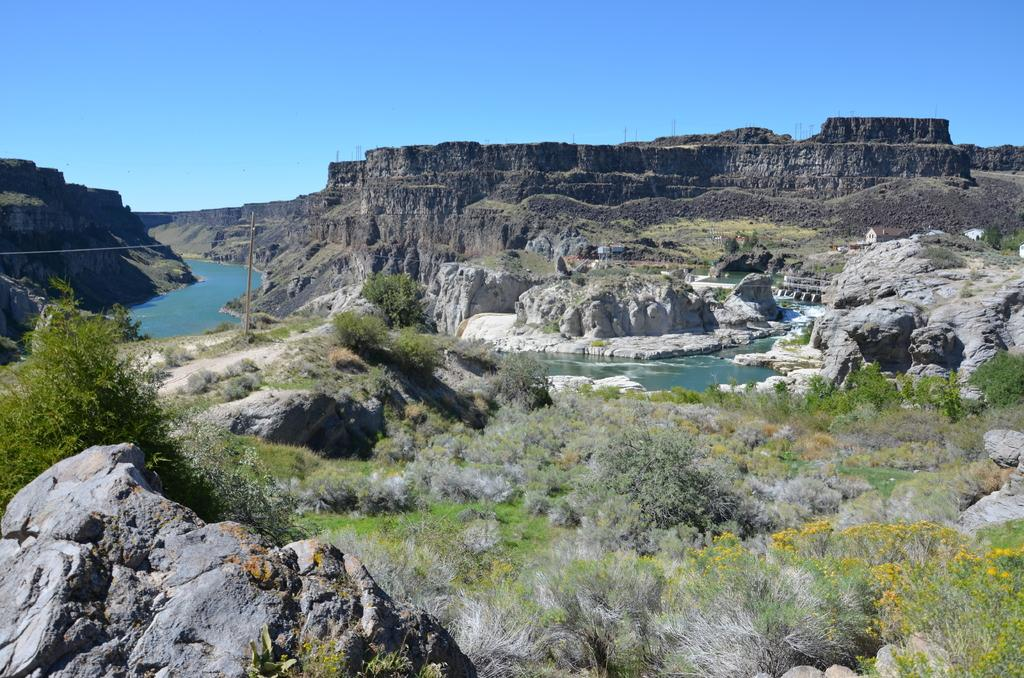What type of water feature is present in the image? There is a canal in the image. What type of geographical feature can be seen in the distance? Hills are visible in the image. What is present at the bottom of the image? Rocks are present at the bottom of the image. What type of vegetation is visible in the image? Grass and trees are visible in the image. What is visible in the background of the image? The sky is visible in the background of the image. What type of dime is being used to protest the voyage in the image? There is no dime, protest, or voyage present in the image. 